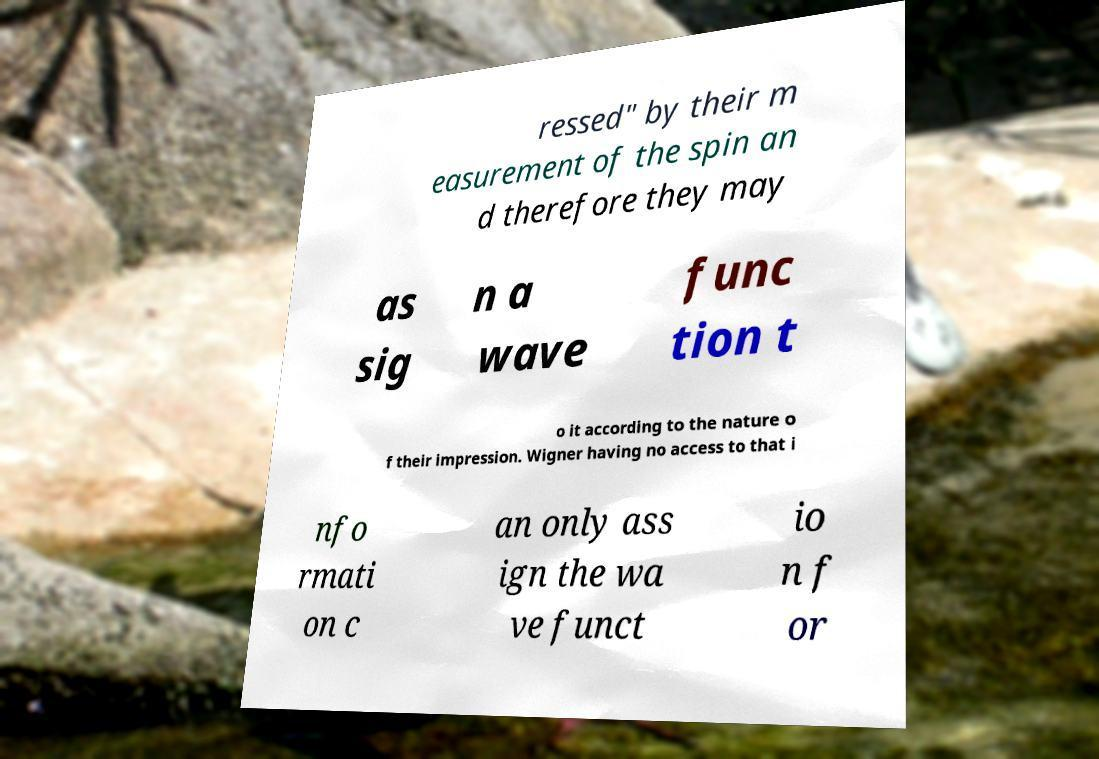I need the written content from this picture converted into text. Can you do that? ressed" by their m easurement of the spin an d therefore they may as sig n a wave func tion t o it according to the nature o f their impression. Wigner having no access to that i nfo rmati on c an only ass ign the wa ve funct io n f or 